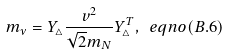<formula> <loc_0><loc_0><loc_500><loc_500>m _ { \nu } = Y _ { \triangle } \frac { v ^ { 2 } } { { \sqrt { 2 } } m _ { N } } Y _ { \triangle } ^ { T } , \ e q n o ( B . 6 )</formula> 